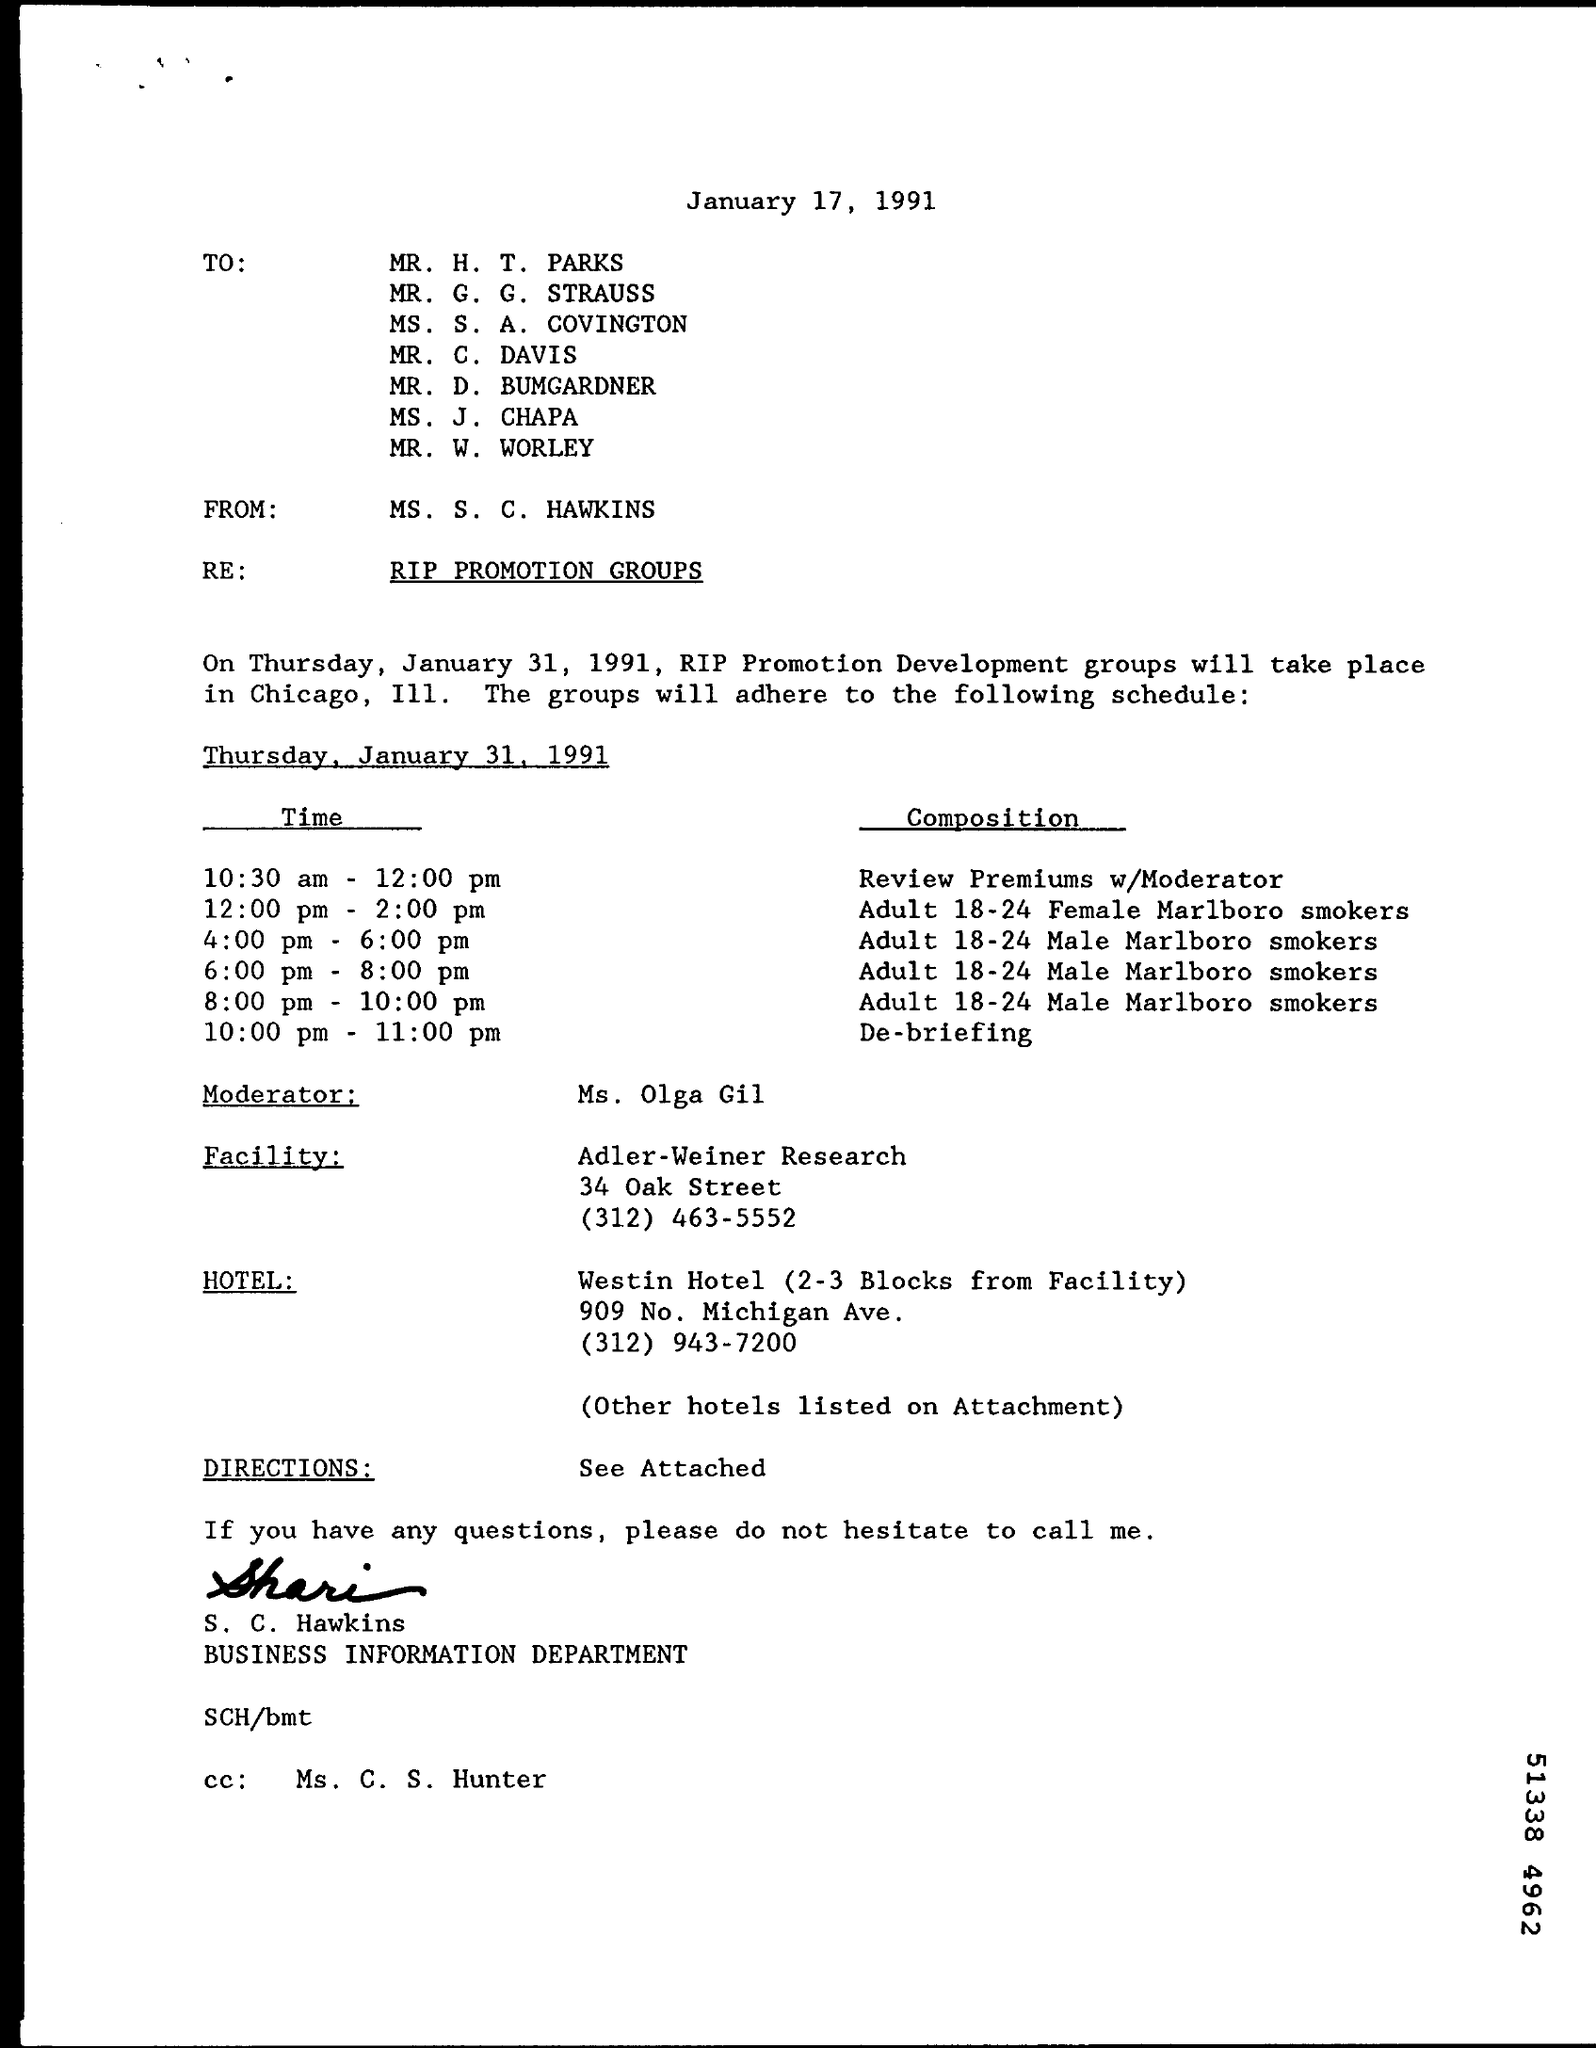Outline some significant characteristics in this image. The moderator referred to in the email is Ms. Olga Gil. The sender of this email is MS. S. C. HAWKINS. At 4:00 pm to 6:00 pm, the composition of adult 18-24 male Marlboro smokers is unknown. At the time of 10:00 pm - 11:00 pm, the composition was being debriefed. The date on which this email was written is January 17, 1991. 